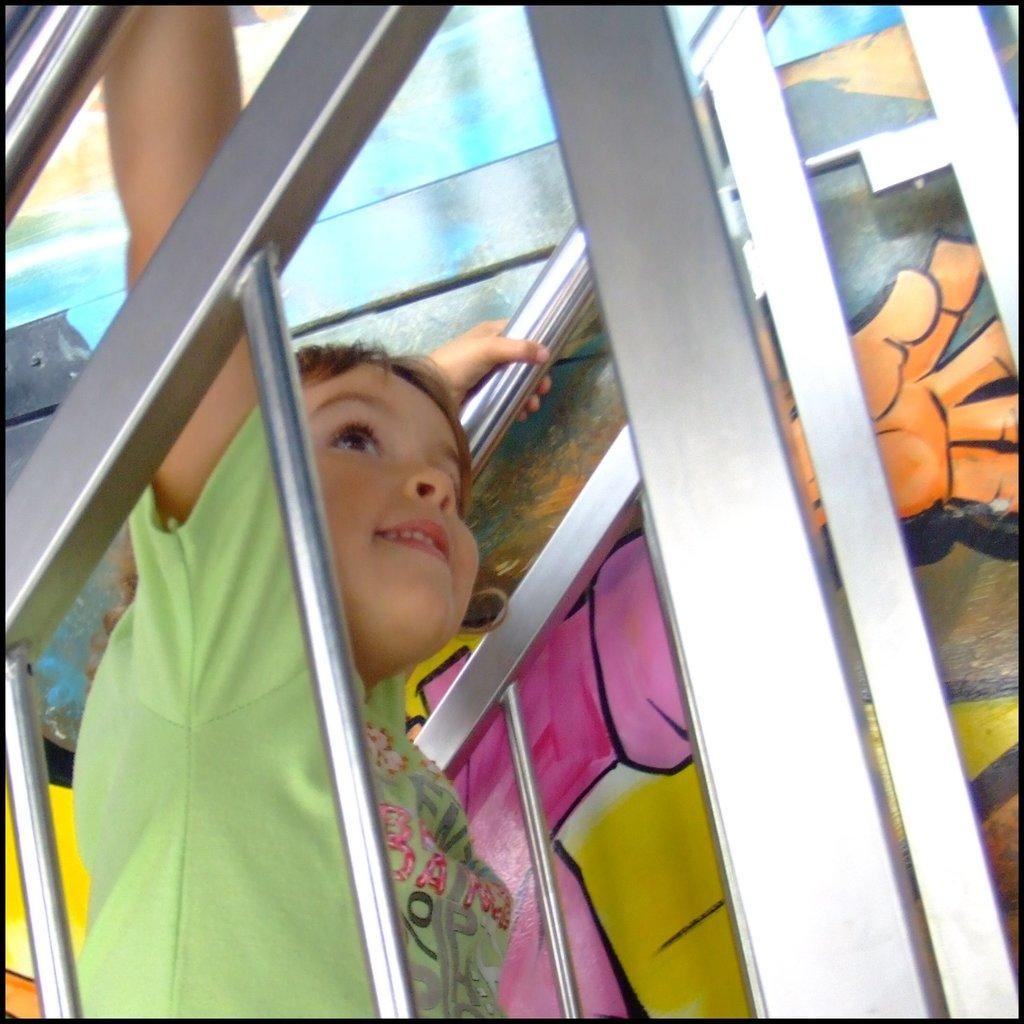What is the main subject of the image? The main subject of the image is a kid. What is the kid's expression in the image? The kid is smiling in the image. What objects are near the kid in the image? There are metal rods beside the kid in the image. What can be seen on the wall in the image? There is a painting on the wall in the image. What type of metal does the kid fear in the image? There is no indication in the image that the kid fears any type of metal. 